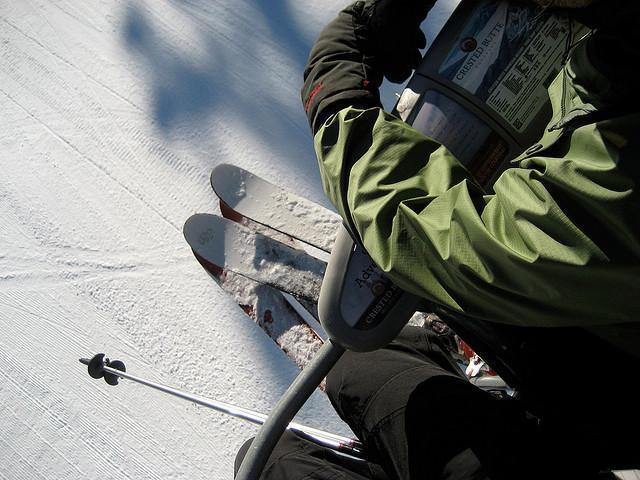What is the person near?
Select the accurate response from the four choices given to answer the question.
Options: Bed, table, ski poles, cow. Ski poles. 